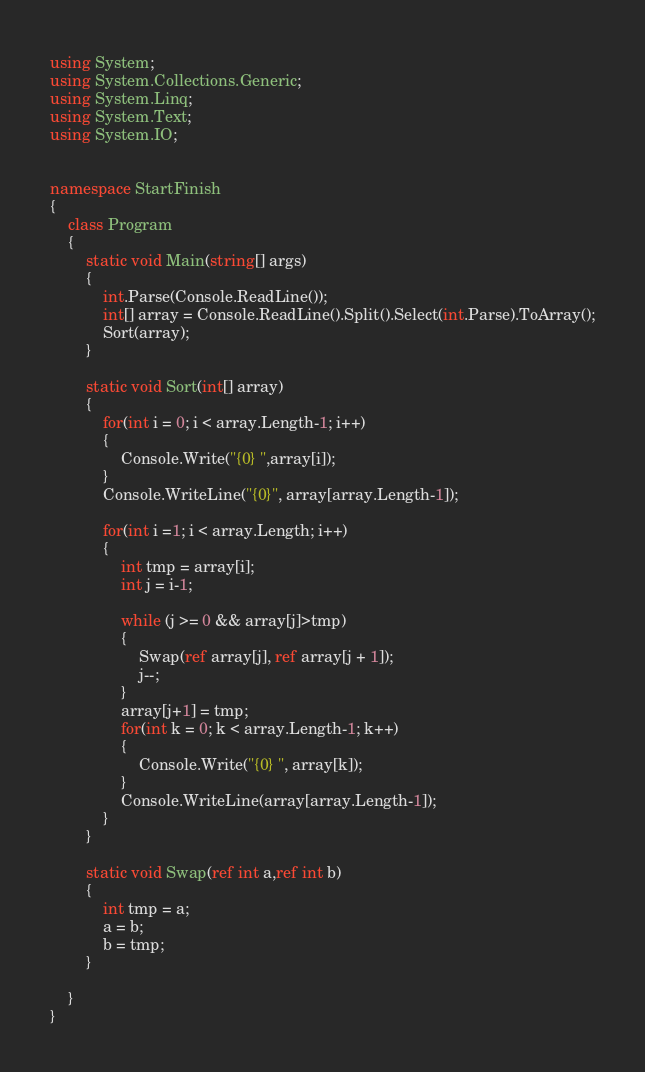<code> <loc_0><loc_0><loc_500><loc_500><_C#_>
using System;
using System.Collections.Generic;
using System.Linq;
using System.Text;
using System.IO;


namespace StartFinish
{
    class Program
    {   
        static void Main(string[] args)
        {
            int.Parse(Console.ReadLine());
            int[] array = Console.ReadLine().Split().Select(int.Parse).ToArray();
            Sort(array);
        }

        static void Sort(int[] array)
        {
            for(int i = 0; i < array.Length-1; i++)
            {
                Console.Write("{0} ",array[i]);
            }
            Console.WriteLine("{0}", array[array.Length-1]);

            for(int i =1; i < array.Length; i++)
            {
                int tmp = array[i];
                int j = i-1;

                while (j >= 0 && array[j]>tmp)
                {
                    Swap(ref array[j], ref array[j + 1]);
                    j--;
                }
                array[j+1] = tmp;
                for(int k = 0; k < array.Length-1; k++)
                {
                    Console.Write("{0} ", array[k]);
                }
                Console.WriteLine(array[array.Length-1]);
            }
        }

        static void Swap(ref int a,ref int b)
        {
            int tmp = a;
            a = b;
            b = tmp;
        }

    }
}</code> 